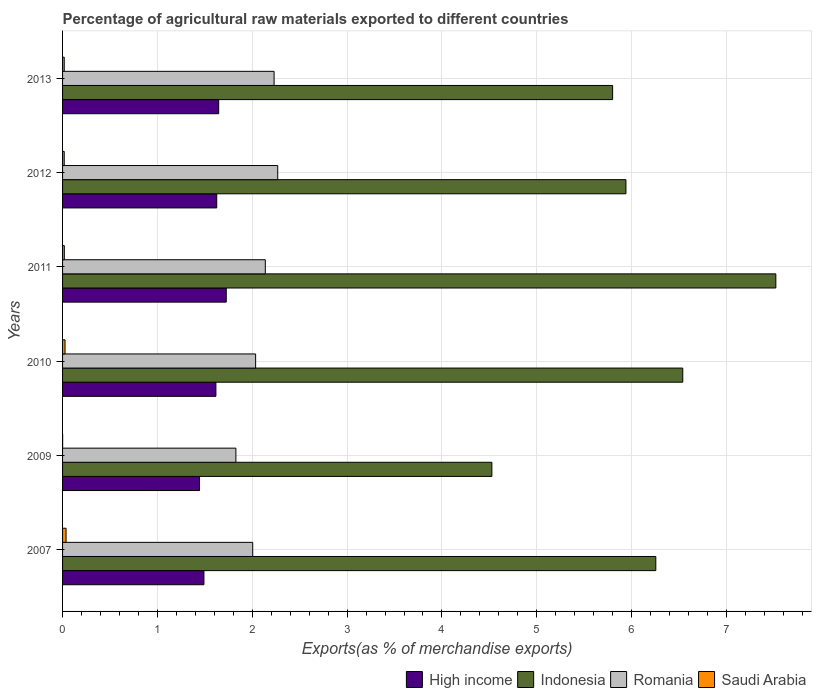How many different coloured bars are there?
Ensure brevity in your answer.  4. How many groups of bars are there?
Provide a short and direct response. 6. Are the number of bars on each tick of the Y-axis equal?
Make the answer very short. Yes. How many bars are there on the 3rd tick from the top?
Your answer should be very brief. 4. How many bars are there on the 6th tick from the bottom?
Keep it short and to the point. 4. In how many cases, is the number of bars for a given year not equal to the number of legend labels?
Give a very brief answer. 0. What is the percentage of exports to different countries in Romania in 2012?
Your answer should be compact. 2.27. Across all years, what is the maximum percentage of exports to different countries in Indonesia?
Keep it short and to the point. 7.52. Across all years, what is the minimum percentage of exports to different countries in High income?
Keep it short and to the point. 1.44. In which year was the percentage of exports to different countries in Indonesia maximum?
Your response must be concise. 2011. In which year was the percentage of exports to different countries in Romania minimum?
Make the answer very short. 2009. What is the total percentage of exports to different countries in Indonesia in the graph?
Keep it short and to the point. 36.58. What is the difference between the percentage of exports to different countries in High income in 2009 and that in 2013?
Offer a terse response. -0.2. What is the difference between the percentage of exports to different countries in Indonesia in 2013 and the percentage of exports to different countries in Romania in 2012?
Provide a short and direct response. 3.53. What is the average percentage of exports to different countries in Indonesia per year?
Your answer should be very brief. 6.1. In the year 2013, what is the difference between the percentage of exports to different countries in Romania and percentage of exports to different countries in Indonesia?
Provide a short and direct response. -3.57. What is the ratio of the percentage of exports to different countries in Saudi Arabia in 2007 to that in 2010?
Make the answer very short. 1.42. Is the percentage of exports to different countries in High income in 2007 less than that in 2013?
Make the answer very short. Yes. What is the difference between the highest and the second highest percentage of exports to different countries in Romania?
Offer a very short reply. 0.04. What is the difference between the highest and the lowest percentage of exports to different countries in Indonesia?
Make the answer very short. 2.99. In how many years, is the percentage of exports to different countries in Saudi Arabia greater than the average percentage of exports to different countries in Saudi Arabia taken over all years?
Keep it short and to the point. 2. Is the sum of the percentage of exports to different countries in Indonesia in 2007 and 2009 greater than the maximum percentage of exports to different countries in High income across all years?
Give a very brief answer. Yes. What does the 3rd bar from the top in 2009 represents?
Offer a terse response. Indonesia. What does the 2nd bar from the bottom in 2007 represents?
Your answer should be compact. Indonesia. How many bars are there?
Give a very brief answer. 24. Are the values on the major ticks of X-axis written in scientific E-notation?
Your answer should be very brief. No. Does the graph contain any zero values?
Provide a succinct answer. No. Where does the legend appear in the graph?
Your answer should be very brief. Bottom right. How many legend labels are there?
Your answer should be very brief. 4. How are the legend labels stacked?
Your response must be concise. Horizontal. What is the title of the graph?
Ensure brevity in your answer.  Percentage of agricultural raw materials exported to different countries. What is the label or title of the X-axis?
Offer a very short reply. Exports(as % of merchandise exports). What is the label or title of the Y-axis?
Your answer should be compact. Years. What is the Exports(as % of merchandise exports) of High income in 2007?
Ensure brevity in your answer.  1.49. What is the Exports(as % of merchandise exports) in Indonesia in 2007?
Your answer should be compact. 6.25. What is the Exports(as % of merchandise exports) of Romania in 2007?
Offer a very short reply. 2. What is the Exports(as % of merchandise exports) of Saudi Arabia in 2007?
Keep it short and to the point. 0.04. What is the Exports(as % of merchandise exports) of High income in 2009?
Your answer should be very brief. 1.44. What is the Exports(as % of merchandise exports) of Indonesia in 2009?
Keep it short and to the point. 4.53. What is the Exports(as % of merchandise exports) in Romania in 2009?
Offer a terse response. 1.83. What is the Exports(as % of merchandise exports) of Saudi Arabia in 2009?
Keep it short and to the point. 0. What is the Exports(as % of merchandise exports) of High income in 2010?
Offer a terse response. 1.62. What is the Exports(as % of merchandise exports) in Indonesia in 2010?
Provide a succinct answer. 6.54. What is the Exports(as % of merchandise exports) in Romania in 2010?
Give a very brief answer. 2.04. What is the Exports(as % of merchandise exports) of Saudi Arabia in 2010?
Make the answer very short. 0.03. What is the Exports(as % of merchandise exports) of High income in 2011?
Offer a terse response. 1.73. What is the Exports(as % of merchandise exports) of Indonesia in 2011?
Keep it short and to the point. 7.52. What is the Exports(as % of merchandise exports) in Romania in 2011?
Provide a short and direct response. 2.14. What is the Exports(as % of merchandise exports) in Saudi Arabia in 2011?
Provide a succinct answer. 0.02. What is the Exports(as % of merchandise exports) of High income in 2012?
Offer a very short reply. 1.63. What is the Exports(as % of merchandise exports) of Indonesia in 2012?
Keep it short and to the point. 5.94. What is the Exports(as % of merchandise exports) in Romania in 2012?
Your answer should be very brief. 2.27. What is the Exports(as % of merchandise exports) in Saudi Arabia in 2012?
Your answer should be compact. 0.02. What is the Exports(as % of merchandise exports) in High income in 2013?
Keep it short and to the point. 1.65. What is the Exports(as % of merchandise exports) of Indonesia in 2013?
Make the answer very short. 5.8. What is the Exports(as % of merchandise exports) of Romania in 2013?
Keep it short and to the point. 2.23. What is the Exports(as % of merchandise exports) of Saudi Arabia in 2013?
Offer a terse response. 0.02. Across all years, what is the maximum Exports(as % of merchandise exports) of High income?
Your answer should be compact. 1.73. Across all years, what is the maximum Exports(as % of merchandise exports) of Indonesia?
Provide a short and direct response. 7.52. Across all years, what is the maximum Exports(as % of merchandise exports) in Romania?
Ensure brevity in your answer.  2.27. Across all years, what is the maximum Exports(as % of merchandise exports) in Saudi Arabia?
Your answer should be compact. 0.04. Across all years, what is the minimum Exports(as % of merchandise exports) in High income?
Provide a short and direct response. 1.44. Across all years, what is the minimum Exports(as % of merchandise exports) in Indonesia?
Your answer should be compact. 4.53. Across all years, what is the minimum Exports(as % of merchandise exports) in Romania?
Give a very brief answer. 1.83. Across all years, what is the minimum Exports(as % of merchandise exports) in Saudi Arabia?
Make the answer very short. 0. What is the total Exports(as % of merchandise exports) of High income in the graph?
Provide a succinct answer. 9.55. What is the total Exports(as % of merchandise exports) in Indonesia in the graph?
Make the answer very short. 36.58. What is the total Exports(as % of merchandise exports) of Romania in the graph?
Keep it short and to the point. 12.5. What is the total Exports(as % of merchandise exports) in Saudi Arabia in the graph?
Provide a short and direct response. 0.12. What is the difference between the Exports(as % of merchandise exports) in High income in 2007 and that in 2009?
Offer a terse response. 0.05. What is the difference between the Exports(as % of merchandise exports) of Indonesia in 2007 and that in 2009?
Give a very brief answer. 1.73. What is the difference between the Exports(as % of merchandise exports) of Romania in 2007 and that in 2009?
Offer a very short reply. 0.18. What is the difference between the Exports(as % of merchandise exports) in Saudi Arabia in 2007 and that in 2009?
Provide a short and direct response. 0.04. What is the difference between the Exports(as % of merchandise exports) in High income in 2007 and that in 2010?
Offer a very short reply. -0.13. What is the difference between the Exports(as % of merchandise exports) in Indonesia in 2007 and that in 2010?
Make the answer very short. -0.28. What is the difference between the Exports(as % of merchandise exports) of Romania in 2007 and that in 2010?
Ensure brevity in your answer.  -0.03. What is the difference between the Exports(as % of merchandise exports) of Saudi Arabia in 2007 and that in 2010?
Ensure brevity in your answer.  0.01. What is the difference between the Exports(as % of merchandise exports) of High income in 2007 and that in 2011?
Your answer should be very brief. -0.24. What is the difference between the Exports(as % of merchandise exports) of Indonesia in 2007 and that in 2011?
Provide a short and direct response. -1.27. What is the difference between the Exports(as % of merchandise exports) of Romania in 2007 and that in 2011?
Your response must be concise. -0.13. What is the difference between the Exports(as % of merchandise exports) of Saudi Arabia in 2007 and that in 2011?
Ensure brevity in your answer.  0.02. What is the difference between the Exports(as % of merchandise exports) of High income in 2007 and that in 2012?
Provide a short and direct response. -0.13. What is the difference between the Exports(as % of merchandise exports) in Indonesia in 2007 and that in 2012?
Offer a very short reply. 0.31. What is the difference between the Exports(as % of merchandise exports) of Romania in 2007 and that in 2012?
Ensure brevity in your answer.  -0.26. What is the difference between the Exports(as % of merchandise exports) in Saudi Arabia in 2007 and that in 2012?
Provide a succinct answer. 0.02. What is the difference between the Exports(as % of merchandise exports) in High income in 2007 and that in 2013?
Your answer should be very brief. -0.16. What is the difference between the Exports(as % of merchandise exports) in Indonesia in 2007 and that in 2013?
Ensure brevity in your answer.  0.46. What is the difference between the Exports(as % of merchandise exports) in Romania in 2007 and that in 2013?
Keep it short and to the point. -0.23. What is the difference between the Exports(as % of merchandise exports) in Saudi Arabia in 2007 and that in 2013?
Provide a succinct answer. 0.02. What is the difference between the Exports(as % of merchandise exports) in High income in 2009 and that in 2010?
Offer a terse response. -0.17. What is the difference between the Exports(as % of merchandise exports) in Indonesia in 2009 and that in 2010?
Your response must be concise. -2.01. What is the difference between the Exports(as % of merchandise exports) in Romania in 2009 and that in 2010?
Your response must be concise. -0.21. What is the difference between the Exports(as % of merchandise exports) of Saudi Arabia in 2009 and that in 2010?
Your response must be concise. -0.03. What is the difference between the Exports(as % of merchandise exports) in High income in 2009 and that in 2011?
Your response must be concise. -0.28. What is the difference between the Exports(as % of merchandise exports) of Indonesia in 2009 and that in 2011?
Make the answer very short. -2.99. What is the difference between the Exports(as % of merchandise exports) of Romania in 2009 and that in 2011?
Your answer should be compact. -0.31. What is the difference between the Exports(as % of merchandise exports) in Saudi Arabia in 2009 and that in 2011?
Ensure brevity in your answer.  -0.02. What is the difference between the Exports(as % of merchandise exports) of High income in 2009 and that in 2012?
Provide a succinct answer. -0.18. What is the difference between the Exports(as % of merchandise exports) of Indonesia in 2009 and that in 2012?
Give a very brief answer. -1.41. What is the difference between the Exports(as % of merchandise exports) in Romania in 2009 and that in 2012?
Make the answer very short. -0.44. What is the difference between the Exports(as % of merchandise exports) in Saudi Arabia in 2009 and that in 2012?
Offer a terse response. -0.02. What is the difference between the Exports(as % of merchandise exports) in High income in 2009 and that in 2013?
Your answer should be very brief. -0.2. What is the difference between the Exports(as % of merchandise exports) of Indonesia in 2009 and that in 2013?
Your answer should be compact. -1.27. What is the difference between the Exports(as % of merchandise exports) of Romania in 2009 and that in 2013?
Your answer should be compact. -0.4. What is the difference between the Exports(as % of merchandise exports) in Saudi Arabia in 2009 and that in 2013?
Offer a very short reply. -0.02. What is the difference between the Exports(as % of merchandise exports) of High income in 2010 and that in 2011?
Offer a terse response. -0.11. What is the difference between the Exports(as % of merchandise exports) of Indonesia in 2010 and that in 2011?
Your response must be concise. -0.98. What is the difference between the Exports(as % of merchandise exports) in Romania in 2010 and that in 2011?
Ensure brevity in your answer.  -0.1. What is the difference between the Exports(as % of merchandise exports) of Saudi Arabia in 2010 and that in 2011?
Make the answer very short. 0.01. What is the difference between the Exports(as % of merchandise exports) of High income in 2010 and that in 2012?
Offer a very short reply. -0.01. What is the difference between the Exports(as % of merchandise exports) of Indonesia in 2010 and that in 2012?
Your response must be concise. 0.6. What is the difference between the Exports(as % of merchandise exports) in Romania in 2010 and that in 2012?
Provide a short and direct response. -0.23. What is the difference between the Exports(as % of merchandise exports) of Saudi Arabia in 2010 and that in 2012?
Provide a succinct answer. 0.01. What is the difference between the Exports(as % of merchandise exports) of High income in 2010 and that in 2013?
Offer a terse response. -0.03. What is the difference between the Exports(as % of merchandise exports) in Indonesia in 2010 and that in 2013?
Your answer should be compact. 0.74. What is the difference between the Exports(as % of merchandise exports) of Romania in 2010 and that in 2013?
Provide a short and direct response. -0.19. What is the difference between the Exports(as % of merchandise exports) of Saudi Arabia in 2010 and that in 2013?
Your response must be concise. 0.01. What is the difference between the Exports(as % of merchandise exports) in High income in 2011 and that in 2012?
Your answer should be very brief. 0.1. What is the difference between the Exports(as % of merchandise exports) of Indonesia in 2011 and that in 2012?
Your answer should be very brief. 1.58. What is the difference between the Exports(as % of merchandise exports) of Romania in 2011 and that in 2012?
Your answer should be compact. -0.13. What is the difference between the Exports(as % of merchandise exports) in Saudi Arabia in 2011 and that in 2012?
Offer a terse response. 0. What is the difference between the Exports(as % of merchandise exports) of High income in 2011 and that in 2013?
Your response must be concise. 0.08. What is the difference between the Exports(as % of merchandise exports) in Indonesia in 2011 and that in 2013?
Offer a very short reply. 1.72. What is the difference between the Exports(as % of merchandise exports) in Romania in 2011 and that in 2013?
Your answer should be very brief. -0.09. What is the difference between the Exports(as % of merchandise exports) in High income in 2012 and that in 2013?
Keep it short and to the point. -0.02. What is the difference between the Exports(as % of merchandise exports) of Indonesia in 2012 and that in 2013?
Your answer should be compact. 0.14. What is the difference between the Exports(as % of merchandise exports) in Romania in 2012 and that in 2013?
Offer a very short reply. 0.04. What is the difference between the Exports(as % of merchandise exports) of Saudi Arabia in 2012 and that in 2013?
Offer a terse response. -0. What is the difference between the Exports(as % of merchandise exports) of High income in 2007 and the Exports(as % of merchandise exports) of Indonesia in 2009?
Ensure brevity in your answer.  -3.04. What is the difference between the Exports(as % of merchandise exports) of High income in 2007 and the Exports(as % of merchandise exports) of Romania in 2009?
Provide a succinct answer. -0.34. What is the difference between the Exports(as % of merchandise exports) of High income in 2007 and the Exports(as % of merchandise exports) of Saudi Arabia in 2009?
Provide a succinct answer. 1.49. What is the difference between the Exports(as % of merchandise exports) of Indonesia in 2007 and the Exports(as % of merchandise exports) of Romania in 2009?
Provide a succinct answer. 4.43. What is the difference between the Exports(as % of merchandise exports) of Indonesia in 2007 and the Exports(as % of merchandise exports) of Saudi Arabia in 2009?
Your answer should be very brief. 6.25. What is the difference between the Exports(as % of merchandise exports) of Romania in 2007 and the Exports(as % of merchandise exports) of Saudi Arabia in 2009?
Ensure brevity in your answer.  2. What is the difference between the Exports(as % of merchandise exports) of High income in 2007 and the Exports(as % of merchandise exports) of Indonesia in 2010?
Offer a very short reply. -5.05. What is the difference between the Exports(as % of merchandise exports) in High income in 2007 and the Exports(as % of merchandise exports) in Romania in 2010?
Your answer should be very brief. -0.54. What is the difference between the Exports(as % of merchandise exports) in High income in 2007 and the Exports(as % of merchandise exports) in Saudi Arabia in 2010?
Give a very brief answer. 1.46. What is the difference between the Exports(as % of merchandise exports) of Indonesia in 2007 and the Exports(as % of merchandise exports) of Romania in 2010?
Ensure brevity in your answer.  4.22. What is the difference between the Exports(as % of merchandise exports) of Indonesia in 2007 and the Exports(as % of merchandise exports) of Saudi Arabia in 2010?
Provide a short and direct response. 6.23. What is the difference between the Exports(as % of merchandise exports) in Romania in 2007 and the Exports(as % of merchandise exports) in Saudi Arabia in 2010?
Ensure brevity in your answer.  1.98. What is the difference between the Exports(as % of merchandise exports) in High income in 2007 and the Exports(as % of merchandise exports) in Indonesia in 2011?
Offer a very short reply. -6.03. What is the difference between the Exports(as % of merchandise exports) in High income in 2007 and the Exports(as % of merchandise exports) in Romania in 2011?
Make the answer very short. -0.65. What is the difference between the Exports(as % of merchandise exports) in High income in 2007 and the Exports(as % of merchandise exports) in Saudi Arabia in 2011?
Give a very brief answer. 1.47. What is the difference between the Exports(as % of merchandise exports) of Indonesia in 2007 and the Exports(as % of merchandise exports) of Romania in 2011?
Your answer should be compact. 4.12. What is the difference between the Exports(as % of merchandise exports) of Indonesia in 2007 and the Exports(as % of merchandise exports) of Saudi Arabia in 2011?
Offer a terse response. 6.24. What is the difference between the Exports(as % of merchandise exports) of Romania in 2007 and the Exports(as % of merchandise exports) of Saudi Arabia in 2011?
Your response must be concise. 1.99. What is the difference between the Exports(as % of merchandise exports) of High income in 2007 and the Exports(as % of merchandise exports) of Indonesia in 2012?
Offer a terse response. -4.45. What is the difference between the Exports(as % of merchandise exports) in High income in 2007 and the Exports(as % of merchandise exports) in Romania in 2012?
Offer a very short reply. -0.78. What is the difference between the Exports(as % of merchandise exports) in High income in 2007 and the Exports(as % of merchandise exports) in Saudi Arabia in 2012?
Provide a short and direct response. 1.47. What is the difference between the Exports(as % of merchandise exports) of Indonesia in 2007 and the Exports(as % of merchandise exports) of Romania in 2012?
Keep it short and to the point. 3.99. What is the difference between the Exports(as % of merchandise exports) in Indonesia in 2007 and the Exports(as % of merchandise exports) in Saudi Arabia in 2012?
Keep it short and to the point. 6.24. What is the difference between the Exports(as % of merchandise exports) of Romania in 2007 and the Exports(as % of merchandise exports) of Saudi Arabia in 2012?
Provide a succinct answer. 1.99. What is the difference between the Exports(as % of merchandise exports) in High income in 2007 and the Exports(as % of merchandise exports) in Indonesia in 2013?
Provide a succinct answer. -4.31. What is the difference between the Exports(as % of merchandise exports) in High income in 2007 and the Exports(as % of merchandise exports) in Romania in 2013?
Make the answer very short. -0.74. What is the difference between the Exports(as % of merchandise exports) in High income in 2007 and the Exports(as % of merchandise exports) in Saudi Arabia in 2013?
Give a very brief answer. 1.47. What is the difference between the Exports(as % of merchandise exports) in Indonesia in 2007 and the Exports(as % of merchandise exports) in Romania in 2013?
Ensure brevity in your answer.  4.02. What is the difference between the Exports(as % of merchandise exports) of Indonesia in 2007 and the Exports(as % of merchandise exports) of Saudi Arabia in 2013?
Your answer should be very brief. 6.24. What is the difference between the Exports(as % of merchandise exports) of Romania in 2007 and the Exports(as % of merchandise exports) of Saudi Arabia in 2013?
Your answer should be compact. 1.99. What is the difference between the Exports(as % of merchandise exports) in High income in 2009 and the Exports(as % of merchandise exports) in Indonesia in 2010?
Offer a very short reply. -5.1. What is the difference between the Exports(as % of merchandise exports) in High income in 2009 and the Exports(as % of merchandise exports) in Romania in 2010?
Provide a short and direct response. -0.59. What is the difference between the Exports(as % of merchandise exports) of High income in 2009 and the Exports(as % of merchandise exports) of Saudi Arabia in 2010?
Offer a very short reply. 1.42. What is the difference between the Exports(as % of merchandise exports) of Indonesia in 2009 and the Exports(as % of merchandise exports) of Romania in 2010?
Your response must be concise. 2.49. What is the difference between the Exports(as % of merchandise exports) in Indonesia in 2009 and the Exports(as % of merchandise exports) in Saudi Arabia in 2010?
Provide a short and direct response. 4.5. What is the difference between the Exports(as % of merchandise exports) in Romania in 2009 and the Exports(as % of merchandise exports) in Saudi Arabia in 2010?
Offer a very short reply. 1.8. What is the difference between the Exports(as % of merchandise exports) in High income in 2009 and the Exports(as % of merchandise exports) in Indonesia in 2011?
Provide a succinct answer. -6.08. What is the difference between the Exports(as % of merchandise exports) in High income in 2009 and the Exports(as % of merchandise exports) in Romania in 2011?
Provide a succinct answer. -0.69. What is the difference between the Exports(as % of merchandise exports) in High income in 2009 and the Exports(as % of merchandise exports) in Saudi Arabia in 2011?
Give a very brief answer. 1.43. What is the difference between the Exports(as % of merchandise exports) of Indonesia in 2009 and the Exports(as % of merchandise exports) of Romania in 2011?
Your response must be concise. 2.39. What is the difference between the Exports(as % of merchandise exports) in Indonesia in 2009 and the Exports(as % of merchandise exports) in Saudi Arabia in 2011?
Ensure brevity in your answer.  4.51. What is the difference between the Exports(as % of merchandise exports) in Romania in 2009 and the Exports(as % of merchandise exports) in Saudi Arabia in 2011?
Provide a succinct answer. 1.81. What is the difference between the Exports(as % of merchandise exports) in High income in 2009 and the Exports(as % of merchandise exports) in Indonesia in 2012?
Make the answer very short. -4.5. What is the difference between the Exports(as % of merchandise exports) in High income in 2009 and the Exports(as % of merchandise exports) in Romania in 2012?
Give a very brief answer. -0.82. What is the difference between the Exports(as % of merchandise exports) of High income in 2009 and the Exports(as % of merchandise exports) of Saudi Arabia in 2012?
Offer a terse response. 1.43. What is the difference between the Exports(as % of merchandise exports) in Indonesia in 2009 and the Exports(as % of merchandise exports) in Romania in 2012?
Keep it short and to the point. 2.26. What is the difference between the Exports(as % of merchandise exports) in Indonesia in 2009 and the Exports(as % of merchandise exports) in Saudi Arabia in 2012?
Give a very brief answer. 4.51. What is the difference between the Exports(as % of merchandise exports) of Romania in 2009 and the Exports(as % of merchandise exports) of Saudi Arabia in 2012?
Provide a short and direct response. 1.81. What is the difference between the Exports(as % of merchandise exports) in High income in 2009 and the Exports(as % of merchandise exports) in Indonesia in 2013?
Offer a terse response. -4.36. What is the difference between the Exports(as % of merchandise exports) in High income in 2009 and the Exports(as % of merchandise exports) in Romania in 2013?
Your answer should be compact. -0.79. What is the difference between the Exports(as % of merchandise exports) in High income in 2009 and the Exports(as % of merchandise exports) in Saudi Arabia in 2013?
Make the answer very short. 1.43. What is the difference between the Exports(as % of merchandise exports) in Indonesia in 2009 and the Exports(as % of merchandise exports) in Romania in 2013?
Your response must be concise. 2.3. What is the difference between the Exports(as % of merchandise exports) in Indonesia in 2009 and the Exports(as % of merchandise exports) in Saudi Arabia in 2013?
Provide a succinct answer. 4.51. What is the difference between the Exports(as % of merchandise exports) of Romania in 2009 and the Exports(as % of merchandise exports) of Saudi Arabia in 2013?
Keep it short and to the point. 1.81. What is the difference between the Exports(as % of merchandise exports) of High income in 2010 and the Exports(as % of merchandise exports) of Indonesia in 2011?
Offer a very short reply. -5.9. What is the difference between the Exports(as % of merchandise exports) of High income in 2010 and the Exports(as % of merchandise exports) of Romania in 2011?
Offer a terse response. -0.52. What is the difference between the Exports(as % of merchandise exports) of High income in 2010 and the Exports(as % of merchandise exports) of Saudi Arabia in 2011?
Ensure brevity in your answer.  1.6. What is the difference between the Exports(as % of merchandise exports) of Indonesia in 2010 and the Exports(as % of merchandise exports) of Romania in 2011?
Make the answer very short. 4.4. What is the difference between the Exports(as % of merchandise exports) of Indonesia in 2010 and the Exports(as % of merchandise exports) of Saudi Arabia in 2011?
Your answer should be compact. 6.52. What is the difference between the Exports(as % of merchandise exports) in Romania in 2010 and the Exports(as % of merchandise exports) in Saudi Arabia in 2011?
Keep it short and to the point. 2.02. What is the difference between the Exports(as % of merchandise exports) in High income in 2010 and the Exports(as % of merchandise exports) in Indonesia in 2012?
Offer a very short reply. -4.32. What is the difference between the Exports(as % of merchandise exports) in High income in 2010 and the Exports(as % of merchandise exports) in Romania in 2012?
Your answer should be very brief. -0.65. What is the difference between the Exports(as % of merchandise exports) of High income in 2010 and the Exports(as % of merchandise exports) of Saudi Arabia in 2012?
Keep it short and to the point. 1.6. What is the difference between the Exports(as % of merchandise exports) in Indonesia in 2010 and the Exports(as % of merchandise exports) in Romania in 2012?
Provide a short and direct response. 4.27. What is the difference between the Exports(as % of merchandise exports) in Indonesia in 2010 and the Exports(as % of merchandise exports) in Saudi Arabia in 2012?
Your response must be concise. 6.52. What is the difference between the Exports(as % of merchandise exports) of Romania in 2010 and the Exports(as % of merchandise exports) of Saudi Arabia in 2012?
Offer a terse response. 2.02. What is the difference between the Exports(as % of merchandise exports) of High income in 2010 and the Exports(as % of merchandise exports) of Indonesia in 2013?
Keep it short and to the point. -4.18. What is the difference between the Exports(as % of merchandise exports) in High income in 2010 and the Exports(as % of merchandise exports) in Romania in 2013?
Offer a terse response. -0.61. What is the difference between the Exports(as % of merchandise exports) in High income in 2010 and the Exports(as % of merchandise exports) in Saudi Arabia in 2013?
Make the answer very short. 1.6. What is the difference between the Exports(as % of merchandise exports) of Indonesia in 2010 and the Exports(as % of merchandise exports) of Romania in 2013?
Give a very brief answer. 4.31. What is the difference between the Exports(as % of merchandise exports) in Indonesia in 2010 and the Exports(as % of merchandise exports) in Saudi Arabia in 2013?
Your answer should be very brief. 6.52. What is the difference between the Exports(as % of merchandise exports) of Romania in 2010 and the Exports(as % of merchandise exports) of Saudi Arabia in 2013?
Offer a terse response. 2.02. What is the difference between the Exports(as % of merchandise exports) in High income in 2011 and the Exports(as % of merchandise exports) in Indonesia in 2012?
Keep it short and to the point. -4.21. What is the difference between the Exports(as % of merchandise exports) in High income in 2011 and the Exports(as % of merchandise exports) in Romania in 2012?
Make the answer very short. -0.54. What is the difference between the Exports(as % of merchandise exports) in High income in 2011 and the Exports(as % of merchandise exports) in Saudi Arabia in 2012?
Ensure brevity in your answer.  1.71. What is the difference between the Exports(as % of merchandise exports) of Indonesia in 2011 and the Exports(as % of merchandise exports) of Romania in 2012?
Provide a short and direct response. 5.25. What is the difference between the Exports(as % of merchandise exports) in Indonesia in 2011 and the Exports(as % of merchandise exports) in Saudi Arabia in 2012?
Provide a succinct answer. 7.5. What is the difference between the Exports(as % of merchandise exports) in Romania in 2011 and the Exports(as % of merchandise exports) in Saudi Arabia in 2012?
Provide a succinct answer. 2.12. What is the difference between the Exports(as % of merchandise exports) in High income in 2011 and the Exports(as % of merchandise exports) in Indonesia in 2013?
Ensure brevity in your answer.  -4.07. What is the difference between the Exports(as % of merchandise exports) of High income in 2011 and the Exports(as % of merchandise exports) of Romania in 2013?
Provide a short and direct response. -0.5. What is the difference between the Exports(as % of merchandise exports) of High income in 2011 and the Exports(as % of merchandise exports) of Saudi Arabia in 2013?
Your answer should be compact. 1.71. What is the difference between the Exports(as % of merchandise exports) of Indonesia in 2011 and the Exports(as % of merchandise exports) of Romania in 2013?
Your response must be concise. 5.29. What is the difference between the Exports(as % of merchandise exports) of Indonesia in 2011 and the Exports(as % of merchandise exports) of Saudi Arabia in 2013?
Your answer should be very brief. 7.5. What is the difference between the Exports(as % of merchandise exports) in Romania in 2011 and the Exports(as % of merchandise exports) in Saudi Arabia in 2013?
Your answer should be very brief. 2.12. What is the difference between the Exports(as % of merchandise exports) in High income in 2012 and the Exports(as % of merchandise exports) in Indonesia in 2013?
Offer a terse response. -4.17. What is the difference between the Exports(as % of merchandise exports) of High income in 2012 and the Exports(as % of merchandise exports) of Romania in 2013?
Offer a very short reply. -0.6. What is the difference between the Exports(as % of merchandise exports) of High income in 2012 and the Exports(as % of merchandise exports) of Saudi Arabia in 2013?
Keep it short and to the point. 1.61. What is the difference between the Exports(as % of merchandise exports) in Indonesia in 2012 and the Exports(as % of merchandise exports) in Romania in 2013?
Keep it short and to the point. 3.71. What is the difference between the Exports(as % of merchandise exports) of Indonesia in 2012 and the Exports(as % of merchandise exports) of Saudi Arabia in 2013?
Keep it short and to the point. 5.92. What is the difference between the Exports(as % of merchandise exports) in Romania in 2012 and the Exports(as % of merchandise exports) in Saudi Arabia in 2013?
Keep it short and to the point. 2.25. What is the average Exports(as % of merchandise exports) in High income per year?
Provide a succinct answer. 1.59. What is the average Exports(as % of merchandise exports) of Indonesia per year?
Ensure brevity in your answer.  6.1. What is the average Exports(as % of merchandise exports) of Romania per year?
Give a very brief answer. 2.08. What is the average Exports(as % of merchandise exports) in Saudi Arabia per year?
Keep it short and to the point. 0.02. In the year 2007, what is the difference between the Exports(as % of merchandise exports) of High income and Exports(as % of merchandise exports) of Indonesia?
Keep it short and to the point. -4.76. In the year 2007, what is the difference between the Exports(as % of merchandise exports) of High income and Exports(as % of merchandise exports) of Romania?
Provide a short and direct response. -0.51. In the year 2007, what is the difference between the Exports(as % of merchandise exports) in High income and Exports(as % of merchandise exports) in Saudi Arabia?
Your answer should be very brief. 1.45. In the year 2007, what is the difference between the Exports(as % of merchandise exports) of Indonesia and Exports(as % of merchandise exports) of Romania?
Your answer should be compact. 4.25. In the year 2007, what is the difference between the Exports(as % of merchandise exports) of Indonesia and Exports(as % of merchandise exports) of Saudi Arabia?
Offer a terse response. 6.22. In the year 2007, what is the difference between the Exports(as % of merchandise exports) of Romania and Exports(as % of merchandise exports) of Saudi Arabia?
Give a very brief answer. 1.97. In the year 2009, what is the difference between the Exports(as % of merchandise exports) of High income and Exports(as % of merchandise exports) of Indonesia?
Ensure brevity in your answer.  -3.08. In the year 2009, what is the difference between the Exports(as % of merchandise exports) of High income and Exports(as % of merchandise exports) of Romania?
Provide a succinct answer. -0.38. In the year 2009, what is the difference between the Exports(as % of merchandise exports) of High income and Exports(as % of merchandise exports) of Saudi Arabia?
Make the answer very short. 1.44. In the year 2009, what is the difference between the Exports(as % of merchandise exports) of Indonesia and Exports(as % of merchandise exports) of Romania?
Make the answer very short. 2.7. In the year 2009, what is the difference between the Exports(as % of merchandise exports) of Indonesia and Exports(as % of merchandise exports) of Saudi Arabia?
Make the answer very short. 4.53. In the year 2009, what is the difference between the Exports(as % of merchandise exports) in Romania and Exports(as % of merchandise exports) in Saudi Arabia?
Offer a very short reply. 1.83. In the year 2010, what is the difference between the Exports(as % of merchandise exports) of High income and Exports(as % of merchandise exports) of Indonesia?
Offer a terse response. -4.92. In the year 2010, what is the difference between the Exports(as % of merchandise exports) of High income and Exports(as % of merchandise exports) of Romania?
Ensure brevity in your answer.  -0.42. In the year 2010, what is the difference between the Exports(as % of merchandise exports) in High income and Exports(as % of merchandise exports) in Saudi Arabia?
Make the answer very short. 1.59. In the year 2010, what is the difference between the Exports(as % of merchandise exports) in Indonesia and Exports(as % of merchandise exports) in Romania?
Offer a very short reply. 4.5. In the year 2010, what is the difference between the Exports(as % of merchandise exports) of Indonesia and Exports(as % of merchandise exports) of Saudi Arabia?
Your answer should be very brief. 6.51. In the year 2010, what is the difference between the Exports(as % of merchandise exports) in Romania and Exports(as % of merchandise exports) in Saudi Arabia?
Your response must be concise. 2.01. In the year 2011, what is the difference between the Exports(as % of merchandise exports) of High income and Exports(as % of merchandise exports) of Indonesia?
Make the answer very short. -5.79. In the year 2011, what is the difference between the Exports(as % of merchandise exports) in High income and Exports(as % of merchandise exports) in Romania?
Keep it short and to the point. -0.41. In the year 2011, what is the difference between the Exports(as % of merchandise exports) of High income and Exports(as % of merchandise exports) of Saudi Arabia?
Offer a very short reply. 1.71. In the year 2011, what is the difference between the Exports(as % of merchandise exports) in Indonesia and Exports(as % of merchandise exports) in Romania?
Ensure brevity in your answer.  5.38. In the year 2011, what is the difference between the Exports(as % of merchandise exports) in Indonesia and Exports(as % of merchandise exports) in Saudi Arabia?
Make the answer very short. 7.5. In the year 2011, what is the difference between the Exports(as % of merchandise exports) of Romania and Exports(as % of merchandise exports) of Saudi Arabia?
Provide a succinct answer. 2.12. In the year 2012, what is the difference between the Exports(as % of merchandise exports) of High income and Exports(as % of merchandise exports) of Indonesia?
Ensure brevity in your answer.  -4.31. In the year 2012, what is the difference between the Exports(as % of merchandise exports) in High income and Exports(as % of merchandise exports) in Romania?
Make the answer very short. -0.64. In the year 2012, what is the difference between the Exports(as % of merchandise exports) of High income and Exports(as % of merchandise exports) of Saudi Arabia?
Make the answer very short. 1.61. In the year 2012, what is the difference between the Exports(as % of merchandise exports) in Indonesia and Exports(as % of merchandise exports) in Romania?
Offer a terse response. 3.67. In the year 2012, what is the difference between the Exports(as % of merchandise exports) of Indonesia and Exports(as % of merchandise exports) of Saudi Arabia?
Your answer should be compact. 5.92. In the year 2012, what is the difference between the Exports(as % of merchandise exports) of Romania and Exports(as % of merchandise exports) of Saudi Arabia?
Your answer should be compact. 2.25. In the year 2013, what is the difference between the Exports(as % of merchandise exports) in High income and Exports(as % of merchandise exports) in Indonesia?
Ensure brevity in your answer.  -4.15. In the year 2013, what is the difference between the Exports(as % of merchandise exports) of High income and Exports(as % of merchandise exports) of Romania?
Your response must be concise. -0.58. In the year 2013, what is the difference between the Exports(as % of merchandise exports) in High income and Exports(as % of merchandise exports) in Saudi Arabia?
Make the answer very short. 1.63. In the year 2013, what is the difference between the Exports(as % of merchandise exports) in Indonesia and Exports(as % of merchandise exports) in Romania?
Make the answer very short. 3.57. In the year 2013, what is the difference between the Exports(as % of merchandise exports) in Indonesia and Exports(as % of merchandise exports) in Saudi Arabia?
Your answer should be very brief. 5.78. In the year 2013, what is the difference between the Exports(as % of merchandise exports) in Romania and Exports(as % of merchandise exports) in Saudi Arabia?
Your response must be concise. 2.21. What is the ratio of the Exports(as % of merchandise exports) of High income in 2007 to that in 2009?
Offer a very short reply. 1.03. What is the ratio of the Exports(as % of merchandise exports) in Indonesia in 2007 to that in 2009?
Your answer should be very brief. 1.38. What is the ratio of the Exports(as % of merchandise exports) of Romania in 2007 to that in 2009?
Provide a succinct answer. 1.1. What is the ratio of the Exports(as % of merchandise exports) in Saudi Arabia in 2007 to that in 2009?
Keep it short and to the point. 65.25. What is the ratio of the Exports(as % of merchandise exports) in High income in 2007 to that in 2010?
Offer a terse response. 0.92. What is the ratio of the Exports(as % of merchandise exports) in Indonesia in 2007 to that in 2010?
Provide a short and direct response. 0.96. What is the ratio of the Exports(as % of merchandise exports) in Saudi Arabia in 2007 to that in 2010?
Your answer should be very brief. 1.42. What is the ratio of the Exports(as % of merchandise exports) in High income in 2007 to that in 2011?
Offer a terse response. 0.86. What is the ratio of the Exports(as % of merchandise exports) in Indonesia in 2007 to that in 2011?
Provide a succinct answer. 0.83. What is the ratio of the Exports(as % of merchandise exports) in Romania in 2007 to that in 2011?
Offer a very short reply. 0.94. What is the ratio of the Exports(as % of merchandise exports) in Saudi Arabia in 2007 to that in 2011?
Your response must be concise. 1.98. What is the ratio of the Exports(as % of merchandise exports) of High income in 2007 to that in 2012?
Offer a very short reply. 0.92. What is the ratio of the Exports(as % of merchandise exports) of Indonesia in 2007 to that in 2012?
Provide a succinct answer. 1.05. What is the ratio of the Exports(as % of merchandise exports) in Romania in 2007 to that in 2012?
Ensure brevity in your answer.  0.88. What is the ratio of the Exports(as % of merchandise exports) of Saudi Arabia in 2007 to that in 2012?
Offer a very short reply. 2.11. What is the ratio of the Exports(as % of merchandise exports) of High income in 2007 to that in 2013?
Ensure brevity in your answer.  0.91. What is the ratio of the Exports(as % of merchandise exports) of Indonesia in 2007 to that in 2013?
Your response must be concise. 1.08. What is the ratio of the Exports(as % of merchandise exports) in Romania in 2007 to that in 2013?
Your answer should be compact. 0.9. What is the ratio of the Exports(as % of merchandise exports) in Saudi Arabia in 2007 to that in 2013?
Provide a short and direct response. 2.09. What is the ratio of the Exports(as % of merchandise exports) of High income in 2009 to that in 2010?
Your answer should be compact. 0.89. What is the ratio of the Exports(as % of merchandise exports) in Indonesia in 2009 to that in 2010?
Provide a short and direct response. 0.69. What is the ratio of the Exports(as % of merchandise exports) of Romania in 2009 to that in 2010?
Offer a terse response. 0.9. What is the ratio of the Exports(as % of merchandise exports) of Saudi Arabia in 2009 to that in 2010?
Give a very brief answer. 0.02. What is the ratio of the Exports(as % of merchandise exports) of High income in 2009 to that in 2011?
Offer a terse response. 0.84. What is the ratio of the Exports(as % of merchandise exports) in Indonesia in 2009 to that in 2011?
Offer a terse response. 0.6. What is the ratio of the Exports(as % of merchandise exports) in Romania in 2009 to that in 2011?
Provide a short and direct response. 0.85. What is the ratio of the Exports(as % of merchandise exports) in Saudi Arabia in 2009 to that in 2011?
Offer a very short reply. 0.03. What is the ratio of the Exports(as % of merchandise exports) of High income in 2009 to that in 2012?
Make the answer very short. 0.89. What is the ratio of the Exports(as % of merchandise exports) of Indonesia in 2009 to that in 2012?
Offer a terse response. 0.76. What is the ratio of the Exports(as % of merchandise exports) in Romania in 2009 to that in 2012?
Your response must be concise. 0.81. What is the ratio of the Exports(as % of merchandise exports) of Saudi Arabia in 2009 to that in 2012?
Your answer should be very brief. 0.03. What is the ratio of the Exports(as % of merchandise exports) of High income in 2009 to that in 2013?
Provide a short and direct response. 0.88. What is the ratio of the Exports(as % of merchandise exports) in Indonesia in 2009 to that in 2013?
Keep it short and to the point. 0.78. What is the ratio of the Exports(as % of merchandise exports) in Romania in 2009 to that in 2013?
Make the answer very short. 0.82. What is the ratio of the Exports(as % of merchandise exports) of Saudi Arabia in 2009 to that in 2013?
Your response must be concise. 0.03. What is the ratio of the Exports(as % of merchandise exports) of High income in 2010 to that in 2011?
Offer a terse response. 0.94. What is the ratio of the Exports(as % of merchandise exports) in Indonesia in 2010 to that in 2011?
Your answer should be very brief. 0.87. What is the ratio of the Exports(as % of merchandise exports) in Romania in 2010 to that in 2011?
Ensure brevity in your answer.  0.95. What is the ratio of the Exports(as % of merchandise exports) in Saudi Arabia in 2010 to that in 2011?
Your answer should be very brief. 1.39. What is the ratio of the Exports(as % of merchandise exports) of High income in 2010 to that in 2012?
Provide a succinct answer. 0.99. What is the ratio of the Exports(as % of merchandise exports) of Indonesia in 2010 to that in 2012?
Provide a short and direct response. 1.1. What is the ratio of the Exports(as % of merchandise exports) of Romania in 2010 to that in 2012?
Keep it short and to the point. 0.9. What is the ratio of the Exports(as % of merchandise exports) in Saudi Arabia in 2010 to that in 2012?
Ensure brevity in your answer.  1.49. What is the ratio of the Exports(as % of merchandise exports) in High income in 2010 to that in 2013?
Give a very brief answer. 0.98. What is the ratio of the Exports(as % of merchandise exports) in Indonesia in 2010 to that in 2013?
Keep it short and to the point. 1.13. What is the ratio of the Exports(as % of merchandise exports) in Romania in 2010 to that in 2013?
Offer a terse response. 0.91. What is the ratio of the Exports(as % of merchandise exports) of Saudi Arabia in 2010 to that in 2013?
Your response must be concise. 1.47. What is the ratio of the Exports(as % of merchandise exports) of High income in 2011 to that in 2012?
Give a very brief answer. 1.06. What is the ratio of the Exports(as % of merchandise exports) of Indonesia in 2011 to that in 2012?
Offer a terse response. 1.27. What is the ratio of the Exports(as % of merchandise exports) of Romania in 2011 to that in 2012?
Make the answer very short. 0.94. What is the ratio of the Exports(as % of merchandise exports) of Saudi Arabia in 2011 to that in 2012?
Make the answer very short. 1.07. What is the ratio of the Exports(as % of merchandise exports) in High income in 2011 to that in 2013?
Your answer should be very brief. 1.05. What is the ratio of the Exports(as % of merchandise exports) in Indonesia in 2011 to that in 2013?
Make the answer very short. 1.3. What is the ratio of the Exports(as % of merchandise exports) of Romania in 2011 to that in 2013?
Give a very brief answer. 0.96. What is the ratio of the Exports(as % of merchandise exports) in Saudi Arabia in 2011 to that in 2013?
Offer a very short reply. 1.06. What is the ratio of the Exports(as % of merchandise exports) of High income in 2012 to that in 2013?
Make the answer very short. 0.99. What is the ratio of the Exports(as % of merchandise exports) in Indonesia in 2012 to that in 2013?
Offer a very short reply. 1.02. What is the ratio of the Exports(as % of merchandise exports) of Romania in 2012 to that in 2013?
Your answer should be compact. 1.02. What is the ratio of the Exports(as % of merchandise exports) of Saudi Arabia in 2012 to that in 2013?
Offer a very short reply. 0.99. What is the difference between the highest and the second highest Exports(as % of merchandise exports) in High income?
Offer a terse response. 0.08. What is the difference between the highest and the second highest Exports(as % of merchandise exports) of Indonesia?
Your answer should be very brief. 0.98. What is the difference between the highest and the second highest Exports(as % of merchandise exports) in Romania?
Provide a short and direct response. 0.04. What is the difference between the highest and the second highest Exports(as % of merchandise exports) of Saudi Arabia?
Provide a short and direct response. 0.01. What is the difference between the highest and the lowest Exports(as % of merchandise exports) in High income?
Keep it short and to the point. 0.28. What is the difference between the highest and the lowest Exports(as % of merchandise exports) of Indonesia?
Offer a terse response. 2.99. What is the difference between the highest and the lowest Exports(as % of merchandise exports) of Romania?
Give a very brief answer. 0.44. What is the difference between the highest and the lowest Exports(as % of merchandise exports) of Saudi Arabia?
Your response must be concise. 0.04. 